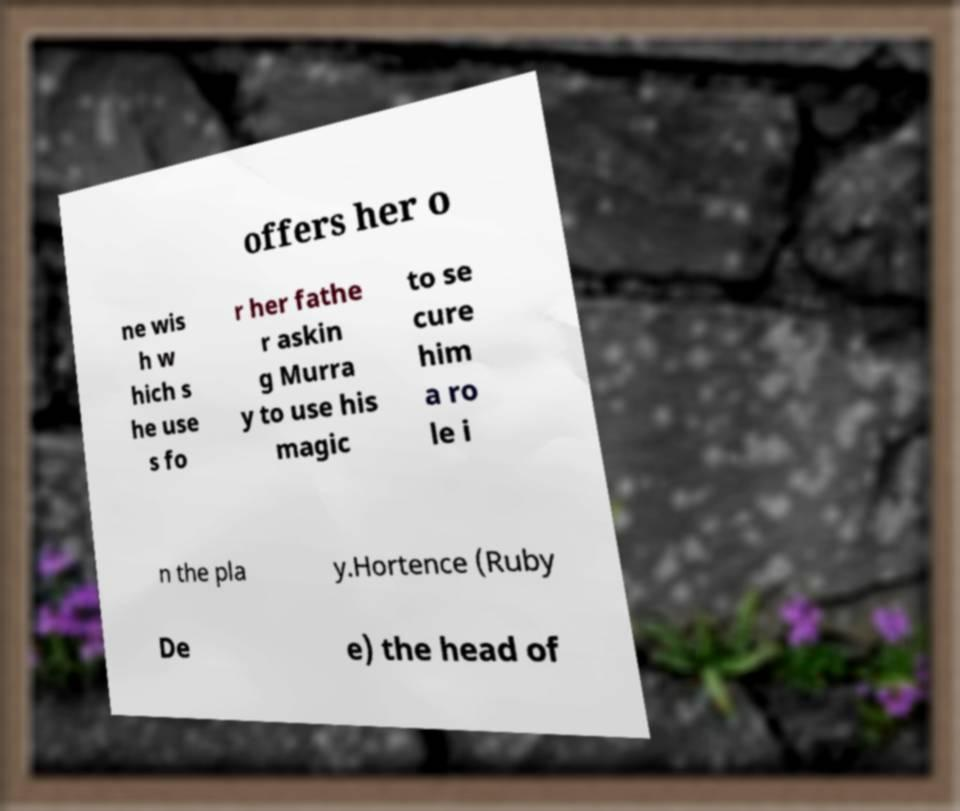What messages or text are displayed in this image? I need them in a readable, typed format. offers her o ne wis h w hich s he use s fo r her fathe r askin g Murra y to use his magic to se cure him a ro le i n the pla y.Hortence (Ruby De e) the head of 